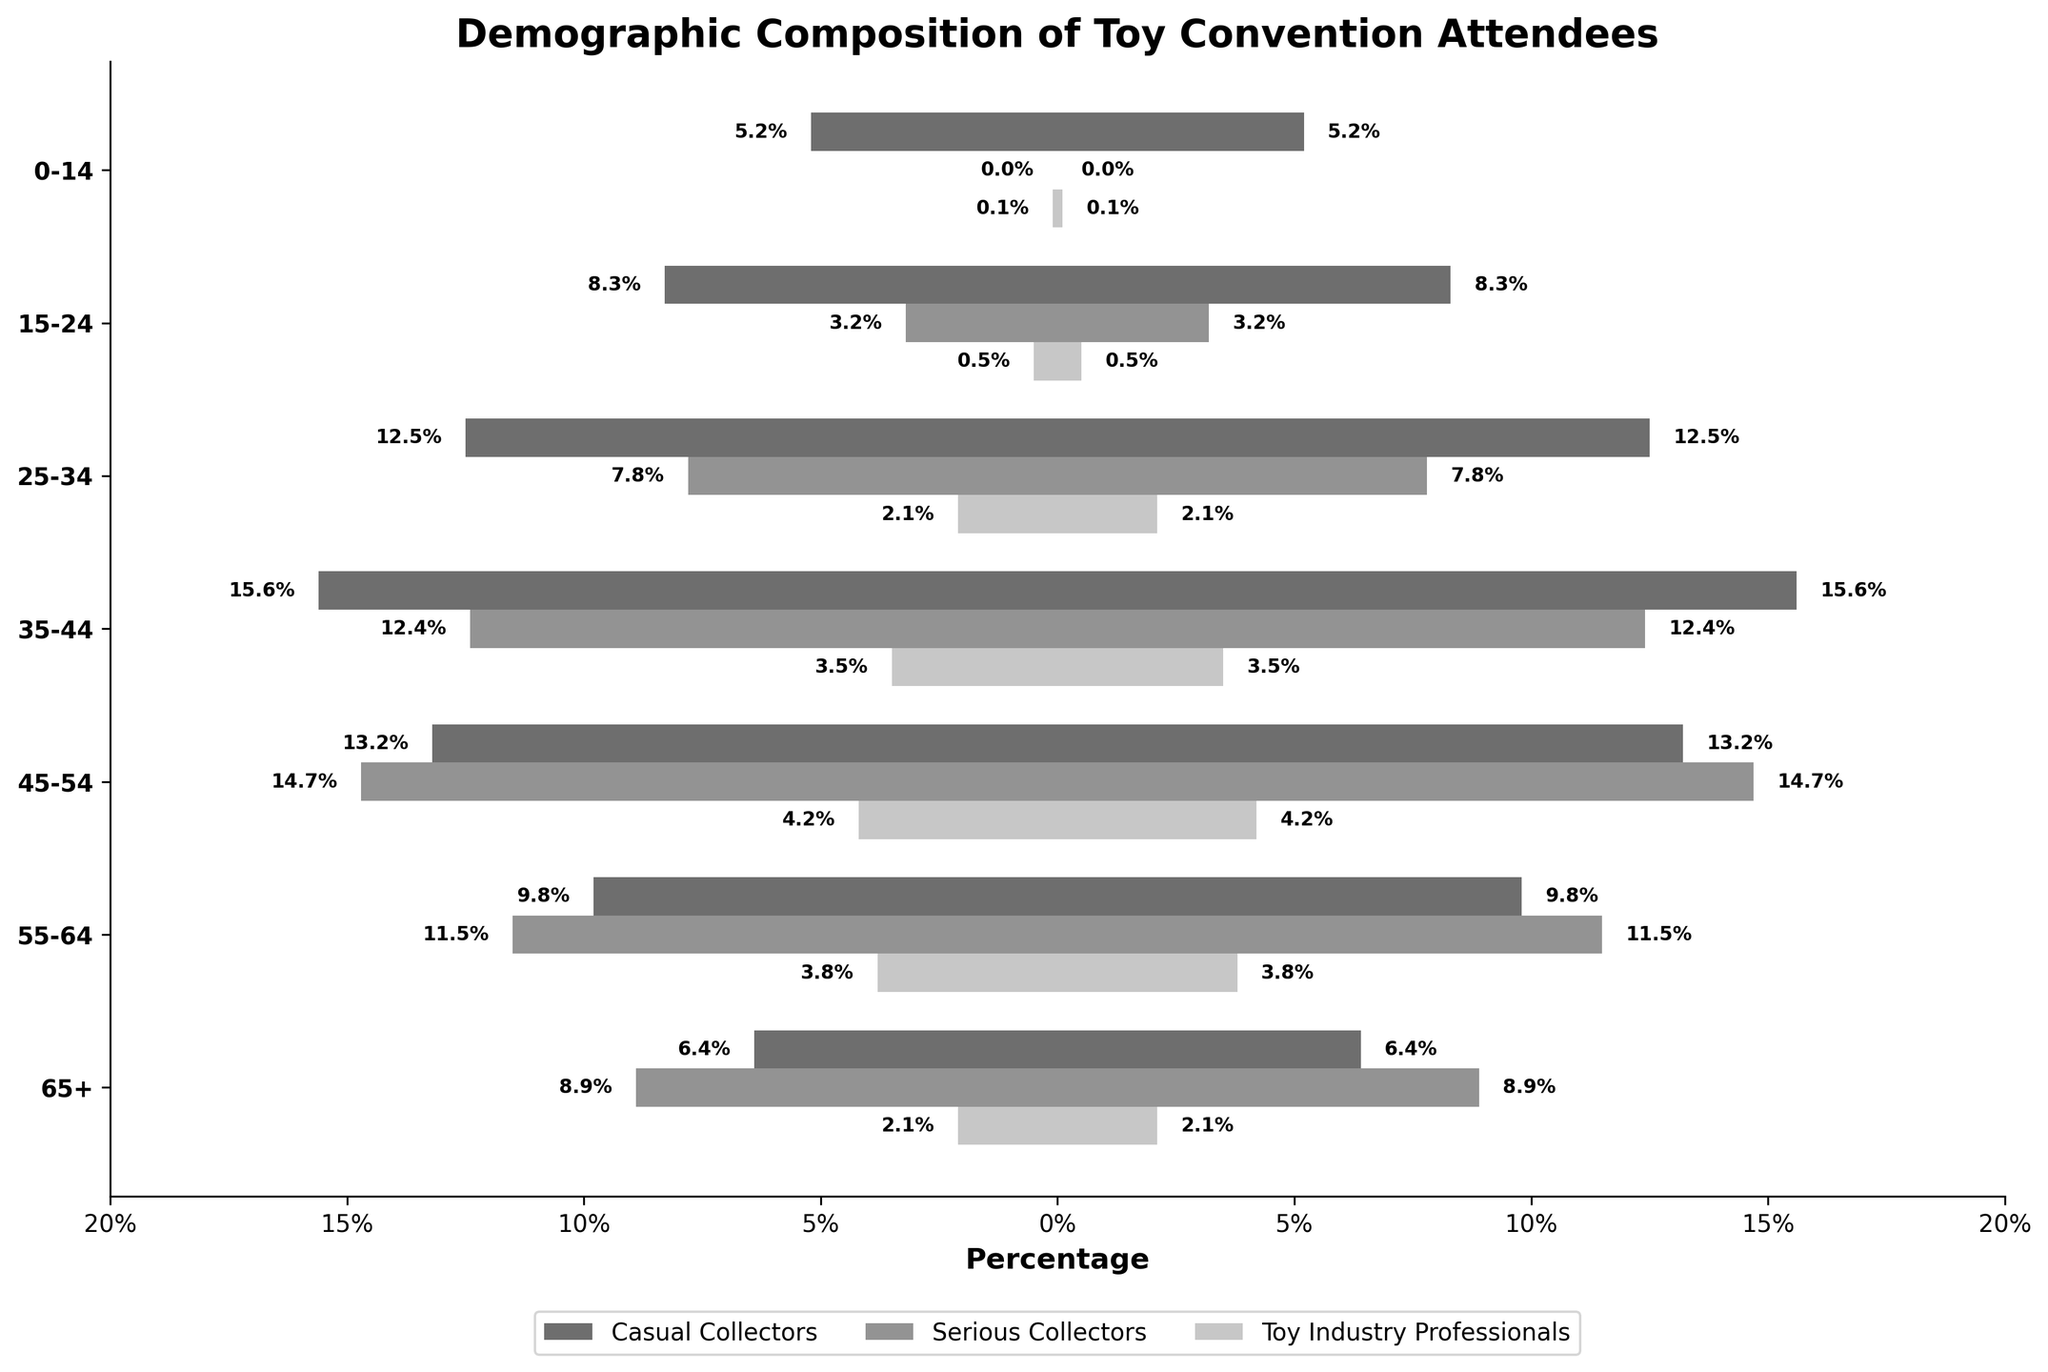What is the title of the chart? The title of the chart is indicated at the top of the figure.
Answer: Demographic Composition of Toy Convention Attendees What age group has the highest percentage of serious collectors? The highest percentage value for serious collectors should be identified. In the 35-44 age group, serious collectors have a percentage of 12.4%, which is the highest.
Answer: 35-44 Which group has the least representation in the 0-14 age category? Comparing the values in the 0-14 age category, Casual Collectors have a percentage of 5.2%, Toy Industry Professionals have 0.1%, and Serious Collectors have 0%. The least is for Serious Collectors.
Answer: Serious Collectors How does the percentage of casual collectors in the 45-54 age group compare to those in the 25-34 age group? Compare the percentages: 13.2% (45-54 age group) vs. 12.5% (25-34 age group).
Answer: The percentage is higher in the 45-54 age group What is the combined percentage of toy industry professionals across all age groups? Add the values given for Toy Industry Professionals for all age groups: 0.1 + 0.5 + 2.1 + 3.5 + 4.2 + 3.8 + 2.1 = 16.3%.
Answer: 16.3% Which age group has the closest percentage of casual and serious collectors? Compare the percentages of casual and serious collectors for each age group: The 0-14 age group has 5.2% (casual) and 0% (serious), 15-24 has 8.3% (casual) and 3.2% (serious), 25-34 has 12.5% (casual) and 7.8% (serious), 35-44 has 15.6% (casual) and 12.4% (serious), 45-54 has 13.2% (casual) and 14.7% (serious), 55-64 has 9.8% (casual) and 11.5% (serious), 65+ has 6.4% (casual) and 8.9% (serious). The 45-54 age group has the closest percentages (13.2% vs. 14.7%).
Answer: 45-54 What's the average percentage of serious collectors for the age groups from 25-44? Add the values and divide by the number of age groups: (7.8 + 12.4) / 2 = 10.1%.
Answer: 10.1% Which collector type has the most consistent percentage across all age groups? By assessing the variations, Casual Collectors' percentages range from 5.2% to 15.6%, Serious Collectors range from 0% to 14.7%, and Toy Industry Professionals range from 0.1% to 4.2%. Toy Industry Professionals have the smallest range of variation.
Answer: Toy Industry Professionals In the 55-64 age group, do serious collectors outnumber toy industry professionals? Compare the percentages of serious collectors and toy industry professionals for the 55-64 age group: 11.5% (serious) vs. 3.8% (toy industry professionals).
Answer: Yes Which age group witnessed the highest combined percentage of collectors (both casual and serious)? Add the percentages for casual and serious collectors for each age group: For 0-14, it is 5.2+0=5.2, for 15-24, it is 8.3+3.2=11.5, for 25-34, it is 12.5+7.8=20.3, for 35-44, it is 15.6+12.4=28, for 45-54, it is 13.2+14.7=27.9, for 55-64, it is 9.8+11.5=21.3, and for 65+, it is 6.4+8.9=15.3. The highest combined percentage is for the 35-44 age group.
Answer: 35-44 